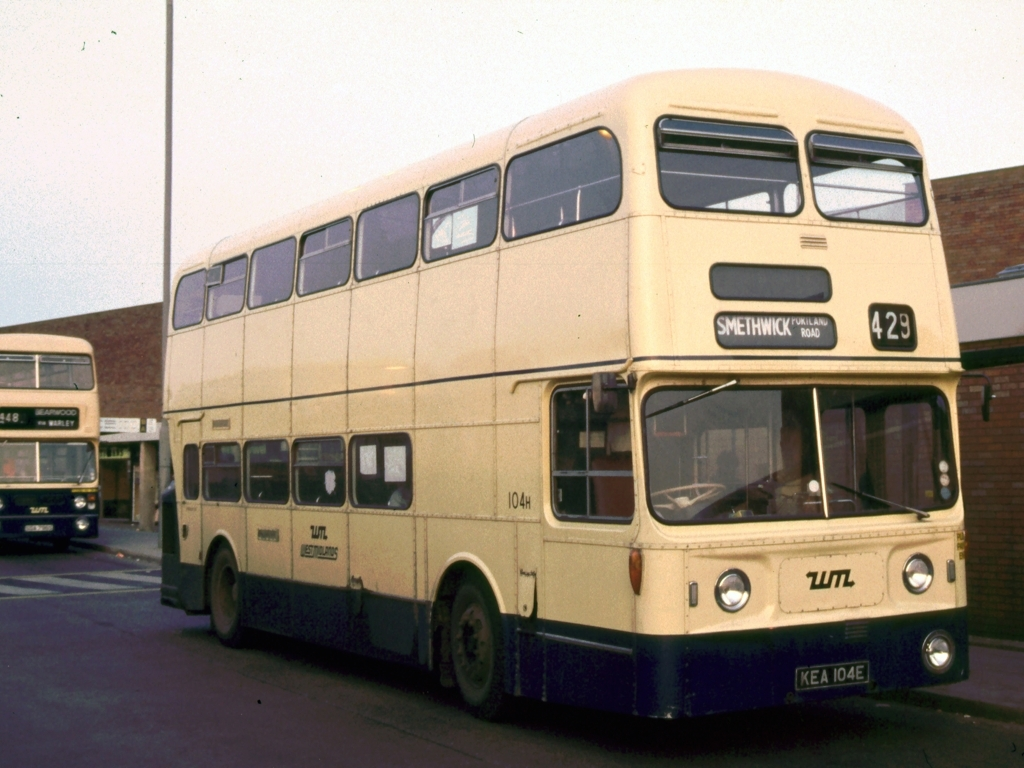Is the texture of the subject relatively clear? The texture of the subject, which is a vintage double-decker bus, appears relatively clear in the image. Details such as the painted surfaces, reflections on the windows, and the tyres' treads are visible, providing a good sense of the bus’s condition and surface textures. 